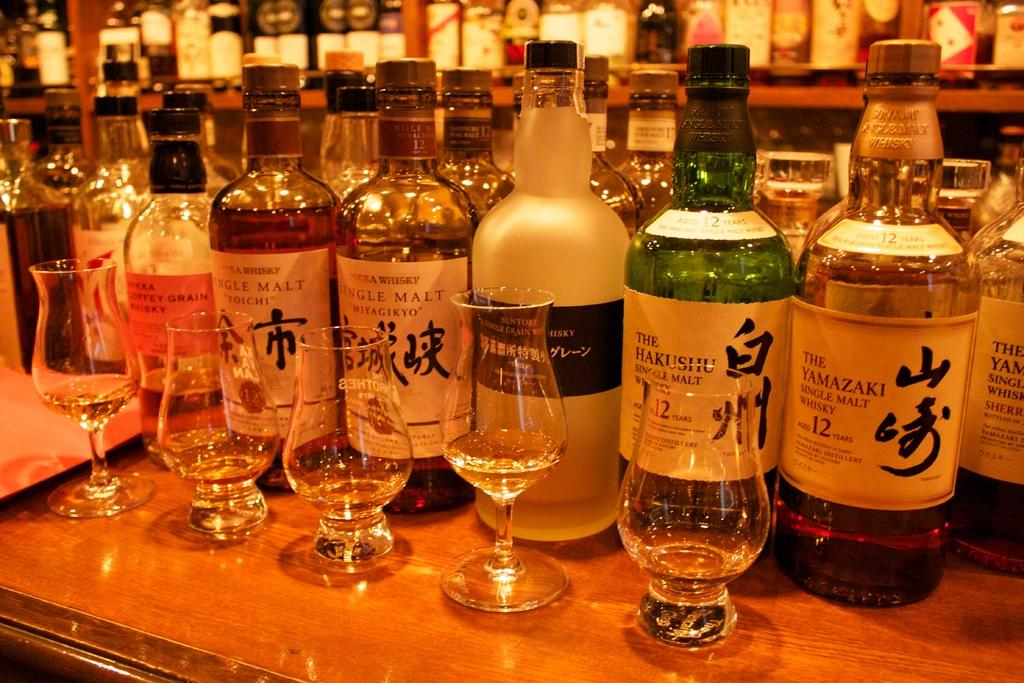Provide a one-sentence caption for the provided image. a Japanese liquor collection with drinking glasses at a bar. 